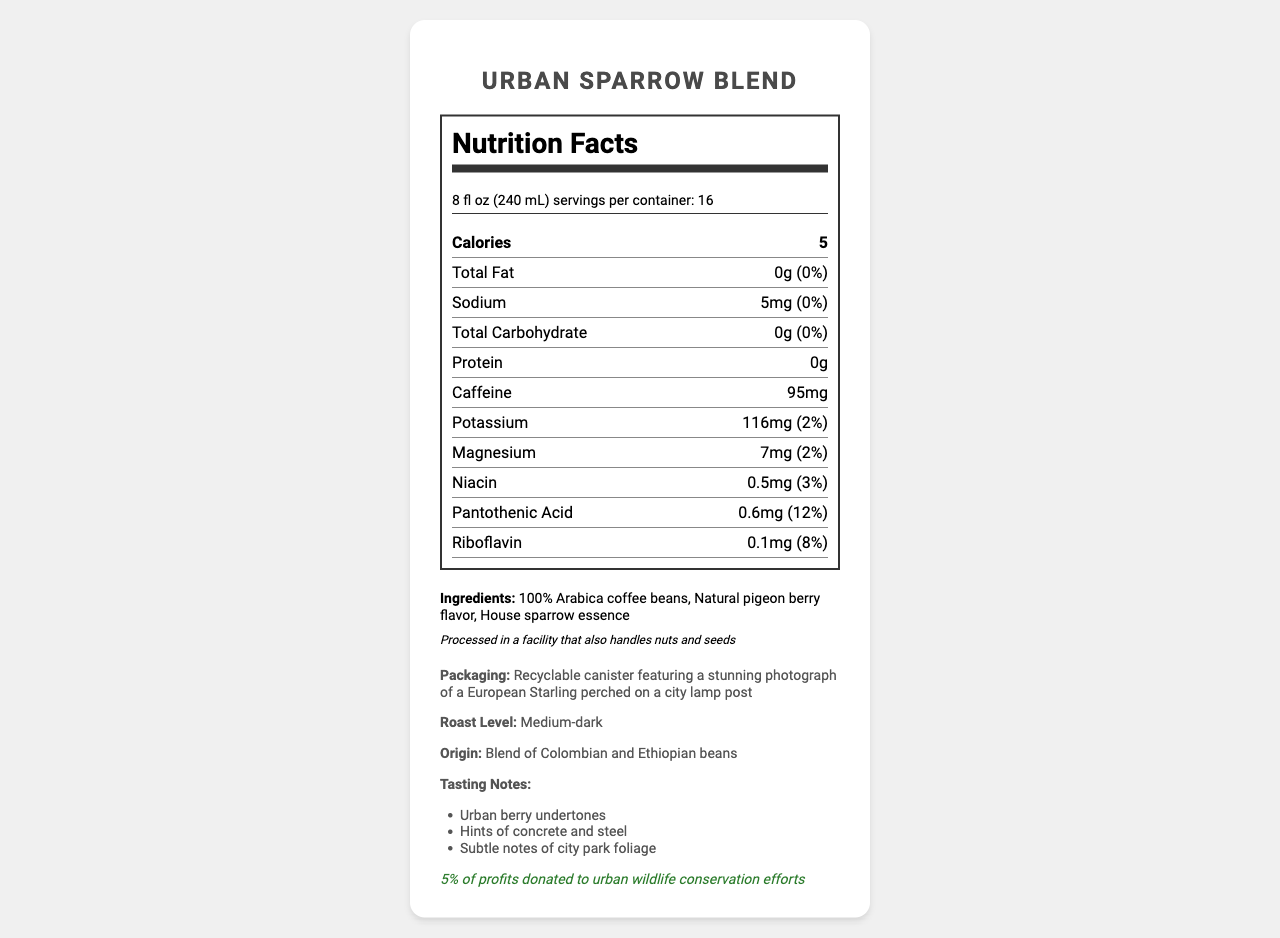what is the serving size? The serving size is explicitly mentioned under the product details section as "8 fl oz (240 mL)".
Answer: 8 fl oz (240 mL) how many servings are there per container? The document states there are 16 servings per container.
Answer: 16 how many calories are in one serving of the Urban Sparrow Blend? The nutrition label lists 5 calories next to the serving information.
Answer: 5 what is the roast level of the Urban Sparrow Blend? The roast level is mentioned in the product information section as "Medium-dark".
Answer: Medium-dark what are the tasting notes of the coffee? The tasting notes are listed under the Product Info section.
Answer: Urban berry undertones, Hints of concrete and steel, Subtle notes of city park foliage what is the caffeine content per serving? The nutrition label lists 95mg under the caffeine content.
Answer: 95mg list three main ingredients of the Urban Sparrow Blend The ingredients are listed explicitly as "100% Arabica coffee beans, Natural pigeon berry flavor, House sparrow essence".
Answer: 100% Arabica coffee beans, Natural pigeon berry flavor, House sparrow essence where are the coffee beans sourced from? The product information specifies the origin as a blend of Colombian and Ethiopian beans.
Answer: Colombia and Ethiopia what is the daily value percentage of Potassium per serving? The nutrition label states 2% as the daily value for Potassium.
Answer: 2% what is the amount of Magnesium in one serving? The nutrition label lists 7mg under the Magnesium content.
Answer: 7mg where can this coffee be purchased? The document does not provide any information about where to purchase the coffee.
Answer: Cannot be determined which vitamin has the highest daily value percentage per serving in Urban Sparrow Blend? A. Niacin B. Pantothenic Acid C. Riboflavin The daily value percentages are listed as 3% for Niacin, 12% for Pantothenic Acid, and 8% for Riboflavin.
Answer: B how many grams of protein are there per serving? The document specifies that each serving contains 0 grams of protein.
Answer: 0g does the packaging feature any photography? The packaging description states that it features a stunning photograph of a European Starling perched on a city lamp post.
Answer: Yes what allergen information is provided on the document? The allergen information section states, "Processed in a facility that also handles nuts and seeds."
Answer: Processed in a facility that also handles nuts and seeds what is the barcode number for the Urban Sparrow Blend package? The barcode number listed in the document is 890123456789.
Answer: 890123456789 summarize the main details provided in the document about Urban Sparrow Blend coffee. The summary includes all highlighted sections such as nutrition facts, origin, flavor notes, ingredients, packaging description, and sustainability efforts.
Answer: Urban Sparrow Blend is a medium-dark roasted coffee made from 100% Arabica beans sourced from Colombia and Ethiopia. It has 5 calories per 8 fl oz serving, with minimal amounts of fat, sodium, carbohydrates, and protein. It contains 95mg of caffeine per serving. The ingredients include natural pigeon berry flavor and house sparrow essence. It is packaged in a recyclable canister with a photograph of a European Starling and a portion of the profits is donated to urban wildlife conservation efforts. what percentage of profits from this product is donated to urban wildlife conservation? The sustainability information section mentions that 5% of profits are donated to urban wildlife conservation efforts.
Answer: 5% 